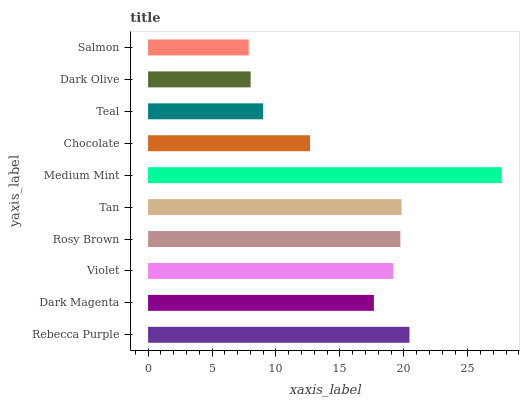Is Salmon the minimum?
Answer yes or no. Yes. Is Medium Mint the maximum?
Answer yes or no. Yes. Is Dark Magenta the minimum?
Answer yes or no. No. Is Dark Magenta the maximum?
Answer yes or no. No. Is Rebecca Purple greater than Dark Magenta?
Answer yes or no. Yes. Is Dark Magenta less than Rebecca Purple?
Answer yes or no. Yes. Is Dark Magenta greater than Rebecca Purple?
Answer yes or no. No. Is Rebecca Purple less than Dark Magenta?
Answer yes or no. No. Is Violet the high median?
Answer yes or no. Yes. Is Dark Magenta the low median?
Answer yes or no. Yes. Is Dark Olive the high median?
Answer yes or no. No. Is Teal the low median?
Answer yes or no. No. 